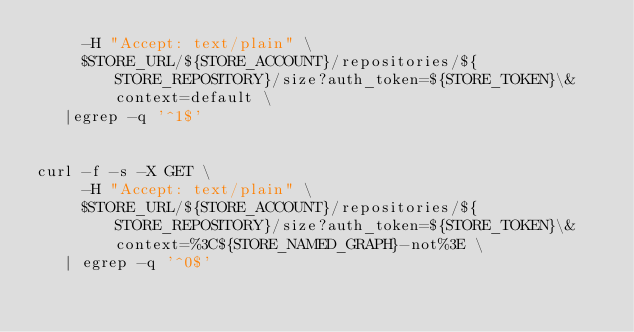Convert code to text. <code><loc_0><loc_0><loc_500><loc_500><_Bash_>     -H "Accept: text/plain" \
     $STORE_URL/${STORE_ACCOUNT}/repositories/${STORE_REPOSITORY}/size?auth_token=${STORE_TOKEN}\&context=default \
   |egrep -q '^1$'


curl -f -s -X GET \
     -H "Accept: text/plain" \
     $STORE_URL/${STORE_ACCOUNT}/repositories/${STORE_REPOSITORY}/size?auth_token=${STORE_TOKEN}\&context=%3C${STORE_NAMED_GRAPH}-not%3E \
   | egrep -q '^0$'

</code> 